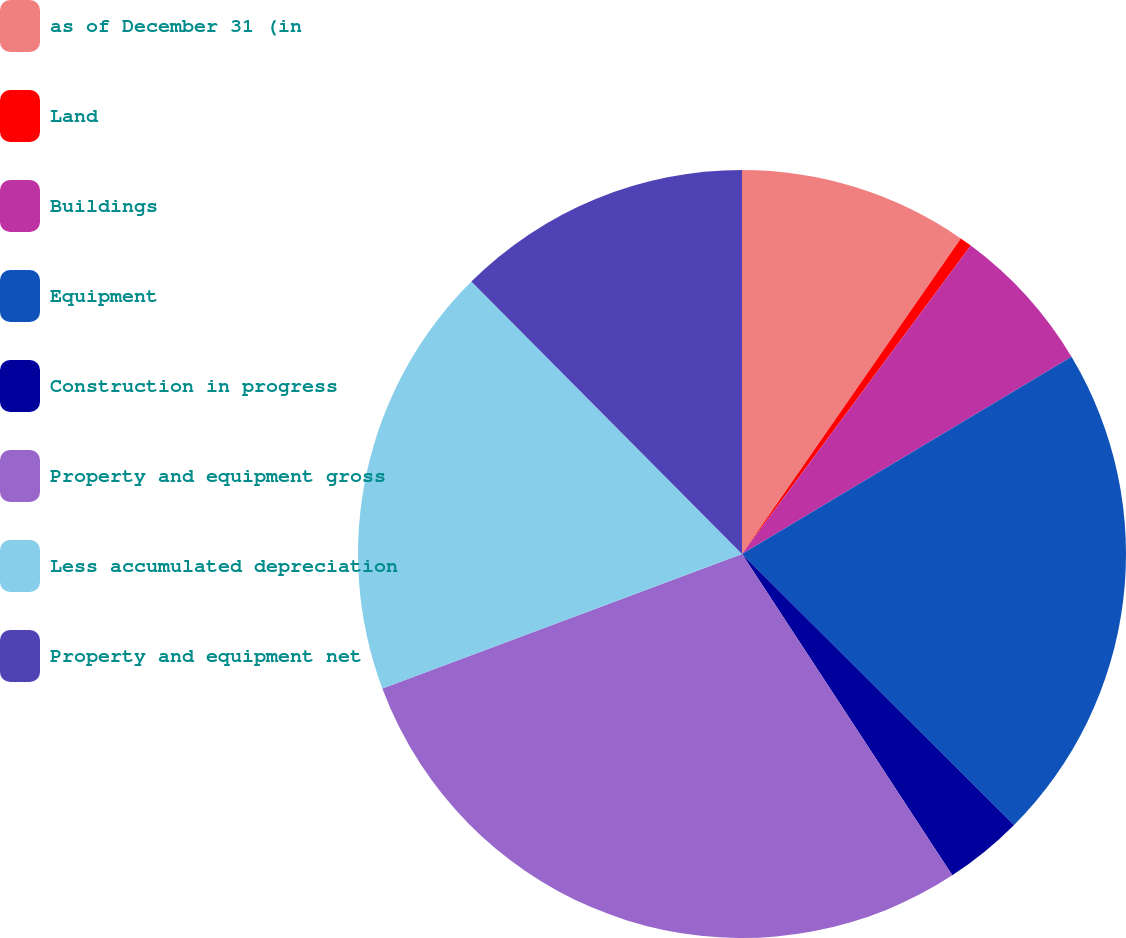Convert chart. <chart><loc_0><loc_0><loc_500><loc_500><pie_chart><fcel>as of December 31 (in<fcel>Land<fcel>Buildings<fcel>Equipment<fcel>Construction in progress<fcel>Property and equipment gross<fcel>Less accumulated depreciation<fcel>Property and equipment net<nl><fcel>9.65%<fcel>0.51%<fcel>6.26%<fcel>21.05%<fcel>3.31%<fcel>28.53%<fcel>18.25%<fcel>12.45%<nl></chart> 